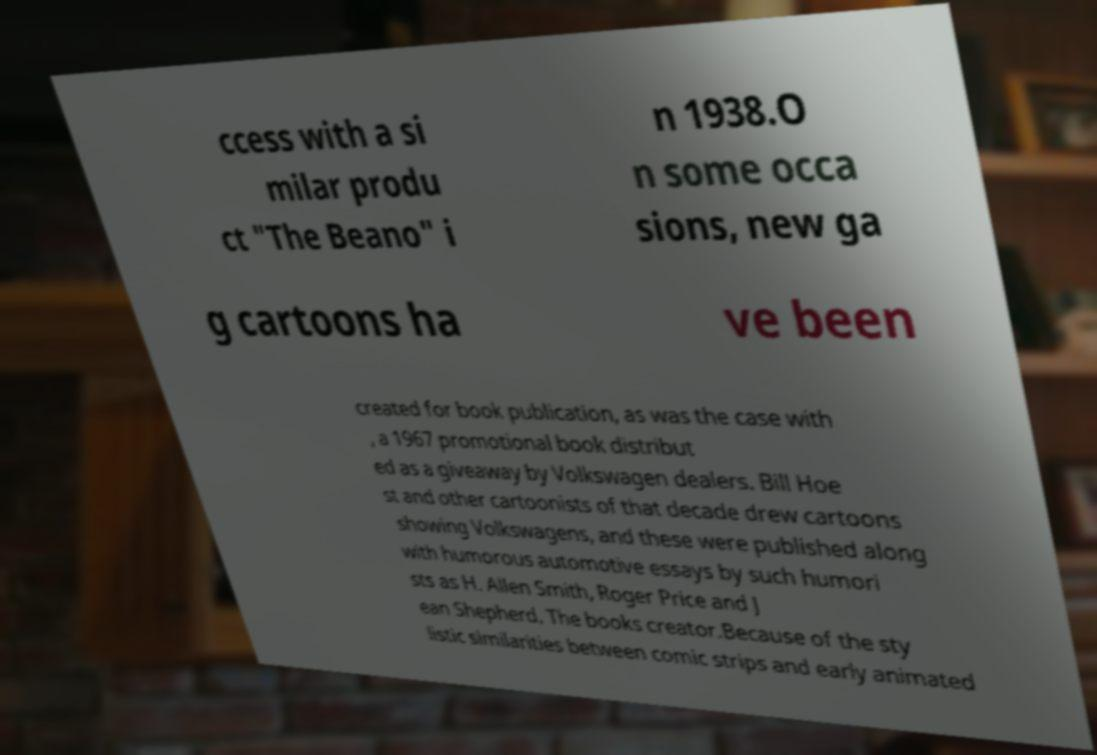There's text embedded in this image that I need extracted. Can you transcribe it verbatim? ccess with a si milar produ ct "The Beano" i n 1938.O n some occa sions, new ga g cartoons ha ve been created for book publication, as was the case with , a 1967 promotional book distribut ed as a giveaway by Volkswagen dealers. Bill Hoe st and other cartoonists of that decade drew cartoons showing Volkswagens, and these were published along with humorous automotive essays by such humori sts as H. Allen Smith, Roger Price and J ean Shepherd. The books creator.Because of the sty listic similarities between comic strips and early animated 